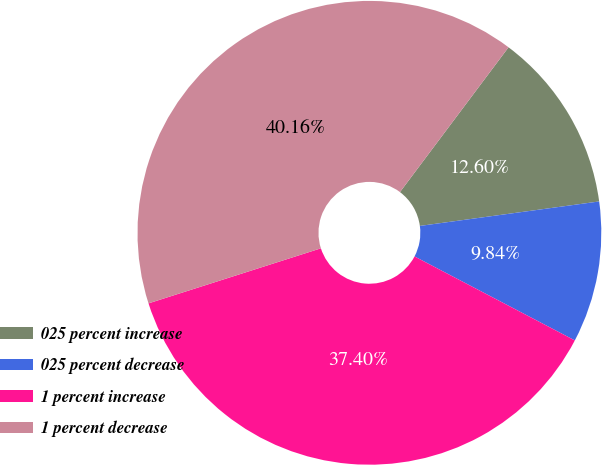Convert chart to OTSL. <chart><loc_0><loc_0><loc_500><loc_500><pie_chart><fcel>025 percent increase<fcel>025 percent decrease<fcel>1 percent increase<fcel>1 percent decrease<nl><fcel>12.6%<fcel>9.84%<fcel>37.4%<fcel>40.16%<nl></chart> 